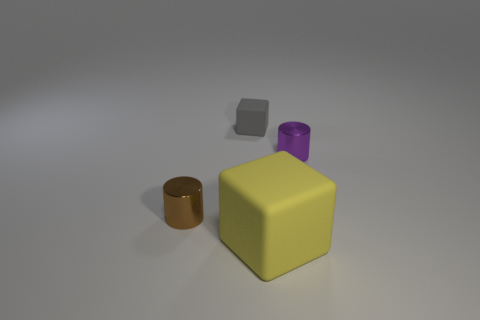There is a brown cylinder that is the same size as the gray object; what is its material?
Provide a succinct answer. Metal. There is a small object that is on the right side of the yellow rubber thing; is its shape the same as the large yellow rubber object?
Ensure brevity in your answer.  No. Does the large rubber cube have the same color as the tiny block?
Give a very brief answer. No. What number of objects are either small metallic things that are to the right of the tiny brown thing or tiny red matte spheres?
Give a very brief answer. 1. What shape is the brown metal thing that is the same size as the purple metal cylinder?
Keep it short and to the point. Cylinder. Does the metallic cylinder to the left of the yellow matte block have the same size as the matte block that is behind the purple cylinder?
Keep it short and to the point. Yes. There is another thing that is made of the same material as the brown object; what color is it?
Your answer should be very brief. Purple. Do the block that is in front of the brown cylinder and the small cylinder that is behind the small brown metal thing have the same material?
Keep it short and to the point. No. Is there a green matte cylinder of the same size as the purple object?
Provide a succinct answer. No. What is the size of the metallic thing on the left side of the thing behind the tiny purple cylinder?
Offer a terse response. Small. 